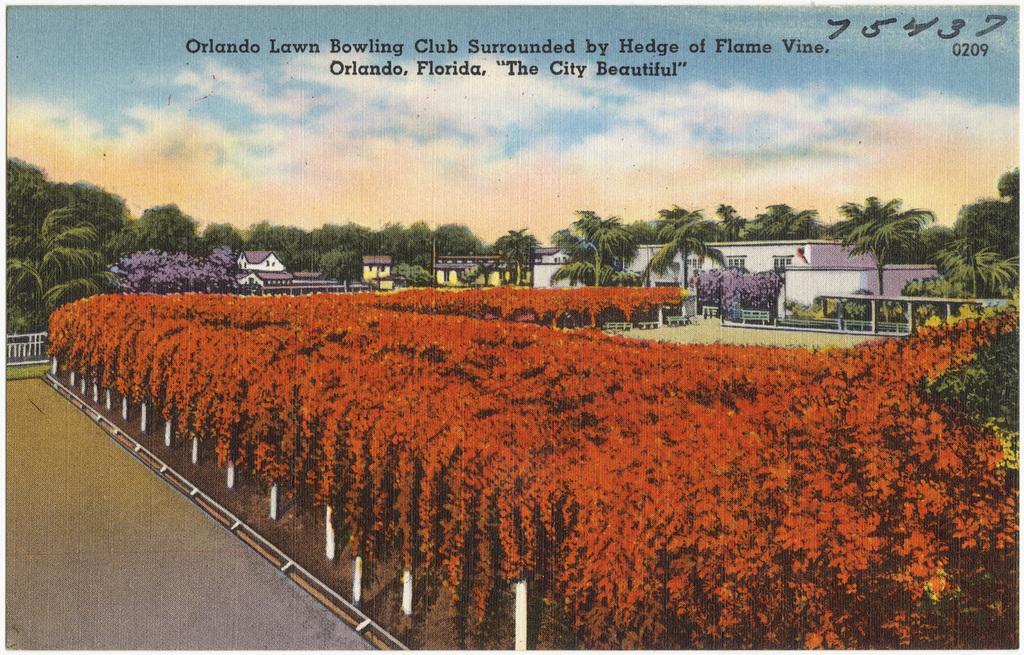Please provide a concise description of this image. In this picture these are the plants in the middle, in the right side there are houses. At the top it's a sky. 